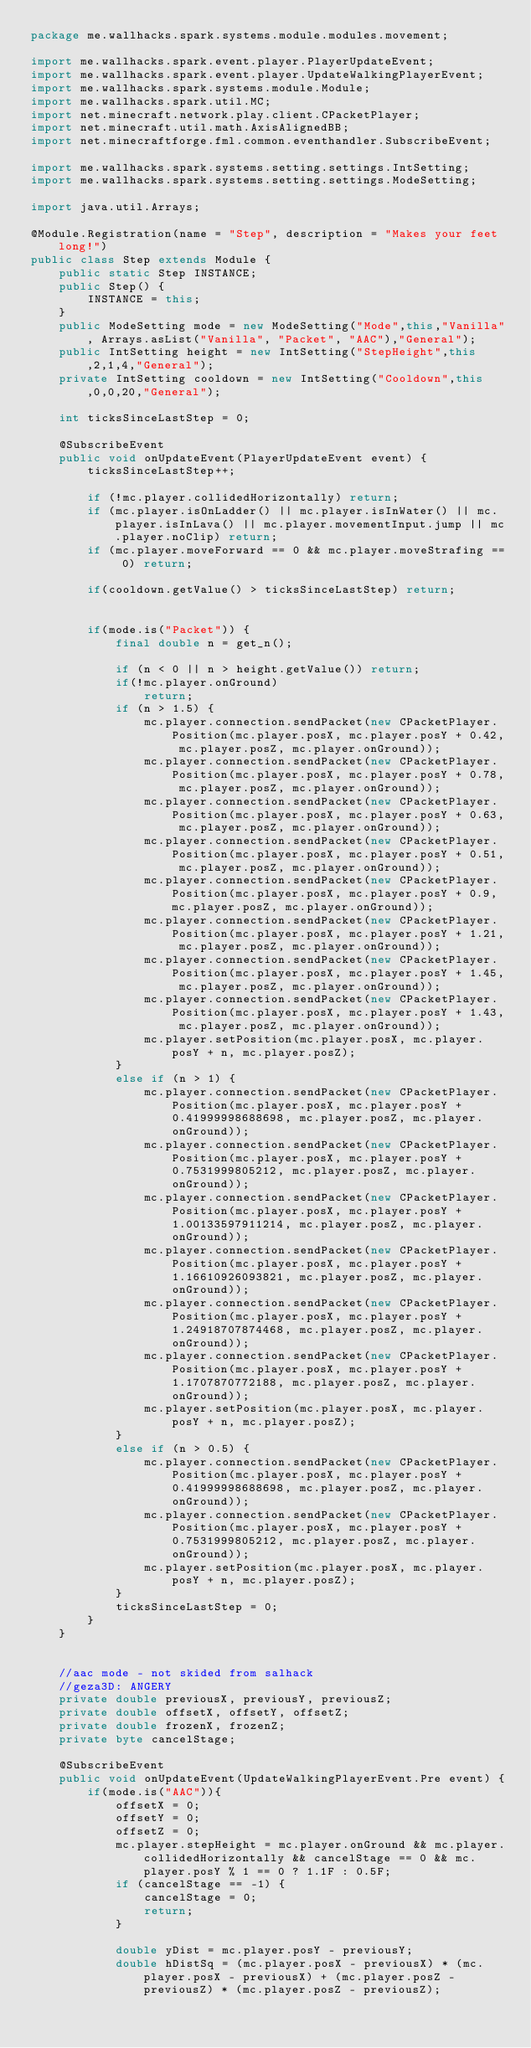Convert code to text. <code><loc_0><loc_0><loc_500><loc_500><_Java_>package me.wallhacks.spark.systems.module.modules.movement;

import me.wallhacks.spark.event.player.PlayerUpdateEvent;
import me.wallhacks.spark.event.player.UpdateWalkingPlayerEvent;
import me.wallhacks.spark.systems.module.Module;
import me.wallhacks.spark.util.MC;
import net.minecraft.network.play.client.CPacketPlayer;
import net.minecraft.util.math.AxisAlignedBB;
import net.minecraftforge.fml.common.eventhandler.SubscribeEvent;

import me.wallhacks.spark.systems.setting.settings.IntSetting;
import me.wallhacks.spark.systems.setting.settings.ModeSetting;

import java.util.Arrays;

@Module.Registration(name = "Step", description = "Makes your feet long!")
public class Step extends Module {
    public static Step INSTANCE;
    public Step() {
        INSTANCE = this;
    }
    public ModeSetting mode = new ModeSetting("Mode",this,"Vanilla", Arrays.asList("Vanilla", "Packet", "AAC"),"General");
    public IntSetting height = new IntSetting("StepHeight",this,2,1,4,"General");
    private IntSetting cooldown = new IntSetting("Cooldown",this,0,0,20,"General");

    int ticksSinceLastStep = 0;

    @SubscribeEvent
    public void onUpdateEvent(PlayerUpdateEvent event) {
        ticksSinceLastStep++;

        if (!mc.player.collidedHorizontally) return;
        if (mc.player.isOnLadder() || mc.player.isInWater() || mc.player.isInLava() || mc.player.movementInput.jump || mc.player.noClip) return;
        if (mc.player.moveForward == 0 && mc.player.moveStrafing == 0) return;

        if(cooldown.getValue() > ticksSinceLastStep) return;


        if(mode.is("Packet")) {
            final double n = get_n();

            if (n < 0 || n > height.getValue()) return;
            if(!mc.player.onGround)
                return;
            if (n > 1.5) {
                mc.player.connection.sendPacket(new CPacketPlayer.Position(mc.player.posX, mc.player.posY + 0.42, mc.player.posZ, mc.player.onGround));
                mc.player.connection.sendPacket(new CPacketPlayer.Position(mc.player.posX, mc.player.posY + 0.78, mc.player.posZ, mc.player.onGround));
                mc.player.connection.sendPacket(new CPacketPlayer.Position(mc.player.posX, mc.player.posY + 0.63, mc.player.posZ, mc.player.onGround));
                mc.player.connection.sendPacket(new CPacketPlayer.Position(mc.player.posX, mc.player.posY + 0.51, mc.player.posZ, mc.player.onGround));
                mc.player.connection.sendPacket(new CPacketPlayer.Position(mc.player.posX, mc.player.posY + 0.9, mc.player.posZ, mc.player.onGround));
                mc.player.connection.sendPacket(new CPacketPlayer.Position(mc.player.posX, mc.player.posY + 1.21, mc.player.posZ, mc.player.onGround));
                mc.player.connection.sendPacket(new CPacketPlayer.Position(mc.player.posX, mc.player.posY + 1.45, mc.player.posZ, mc.player.onGround));
                mc.player.connection.sendPacket(new CPacketPlayer.Position(mc.player.posX, mc.player.posY + 1.43, mc.player.posZ, mc.player.onGround));
                mc.player.setPosition(mc.player.posX, mc.player.posY + n, mc.player.posZ);
            }
            else if (n > 1) {
                mc.player.connection.sendPacket(new CPacketPlayer.Position(mc.player.posX, mc.player.posY + 0.41999998688698, mc.player.posZ, mc.player.onGround));
                mc.player.connection.sendPacket(new CPacketPlayer.Position(mc.player.posX, mc.player.posY + 0.7531999805212, mc.player.posZ, mc.player.onGround));
                mc.player.connection.sendPacket(new CPacketPlayer.Position(mc.player.posX, mc.player.posY + 1.00133597911214, mc.player.posZ, mc.player.onGround));
                mc.player.connection.sendPacket(new CPacketPlayer.Position(mc.player.posX, mc.player.posY + 1.16610926093821, mc.player.posZ, mc.player.onGround));
                mc.player.connection.sendPacket(new CPacketPlayer.Position(mc.player.posX, mc.player.posY + 1.24918707874468, mc.player.posZ, mc.player.onGround));
                mc.player.connection.sendPacket(new CPacketPlayer.Position(mc.player.posX, mc.player.posY + 1.1707870772188, mc.player.posZ, mc.player.onGround));
                mc.player.setPosition(mc.player.posX, mc.player.posY + n, mc.player.posZ);
            }
            else if (n > 0.5) {
                mc.player.connection.sendPacket(new CPacketPlayer.Position(mc.player.posX, mc.player.posY + 0.41999998688698, mc.player.posZ, mc.player.onGround));
                mc.player.connection.sendPacket(new CPacketPlayer.Position(mc.player.posX, mc.player.posY + 0.7531999805212, mc.player.posZ, mc.player.onGround));
                mc.player.setPosition(mc.player.posX, mc.player.posY + n, mc.player.posZ);
            }
            ticksSinceLastStep = 0;
        }
    }


    //aac mode - not skided from salhack
    //geza3D: ANGERY
    private double previousX, previousY, previousZ;
    private double offsetX, offsetY, offsetZ;
    private double frozenX, frozenZ;
    private byte cancelStage;

    @SubscribeEvent
    public void onUpdateEvent(UpdateWalkingPlayerEvent.Pre event) {
        if(mode.is("AAC")){
            offsetX = 0;
            offsetY = 0;
            offsetZ = 0;
            mc.player.stepHeight = mc.player.onGround && mc.player.collidedHorizontally && cancelStage == 0 && mc.player.posY % 1 == 0 ? 1.1F : 0.5F;
            if (cancelStage == -1) {
                cancelStage = 0;
                return;
            }

            double yDist = mc.player.posY - previousY;
            double hDistSq = (mc.player.posX - previousX) * (mc.player.posX - previousX) + (mc.player.posZ - previousZ) * (mc.player.posZ - previousZ);
</code> 